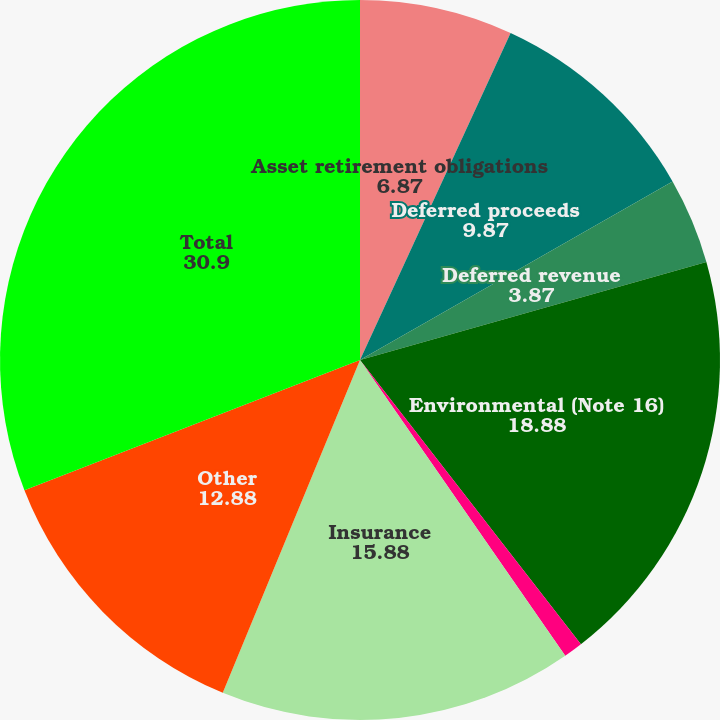Convert chart to OTSL. <chart><loc_0><loc_0><loc_500><loc_500><pie_chart><fcel>Asset retirement obligations<fcel>Deferred proceeds<fcel>Deferred revenue<fcel>Environmental (Note 16)<fcel>Income taxes payable<fcel>Insurance<fcel>Other<fcel>Total<nl><fcel>6.87%<fcel>9.87%<fcel>3.87%<fcel>18.88%<fcel>0.86%<fcel>15.88%<fcel>12.88%<fcel>30.9%<nl></chart> 